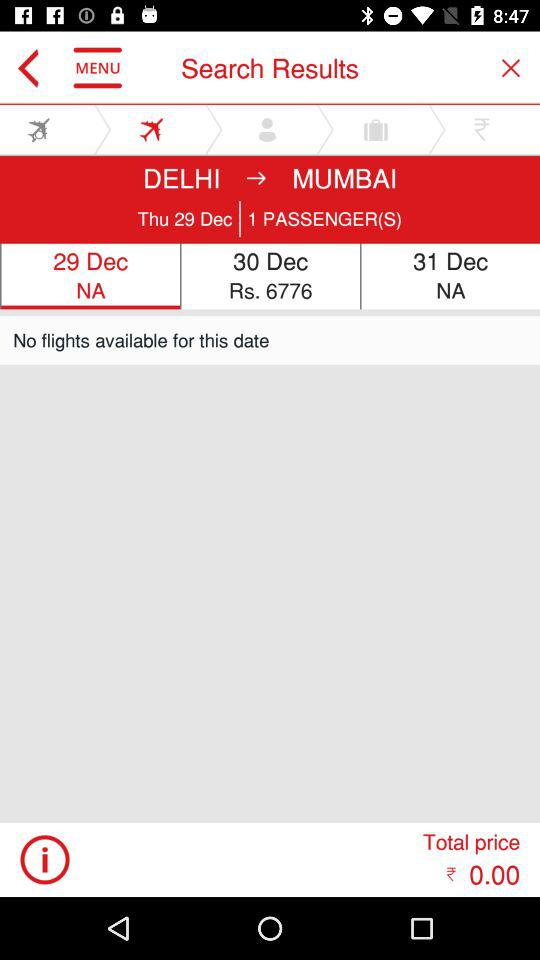What is the number of passengers? The number of passengers is 1. 